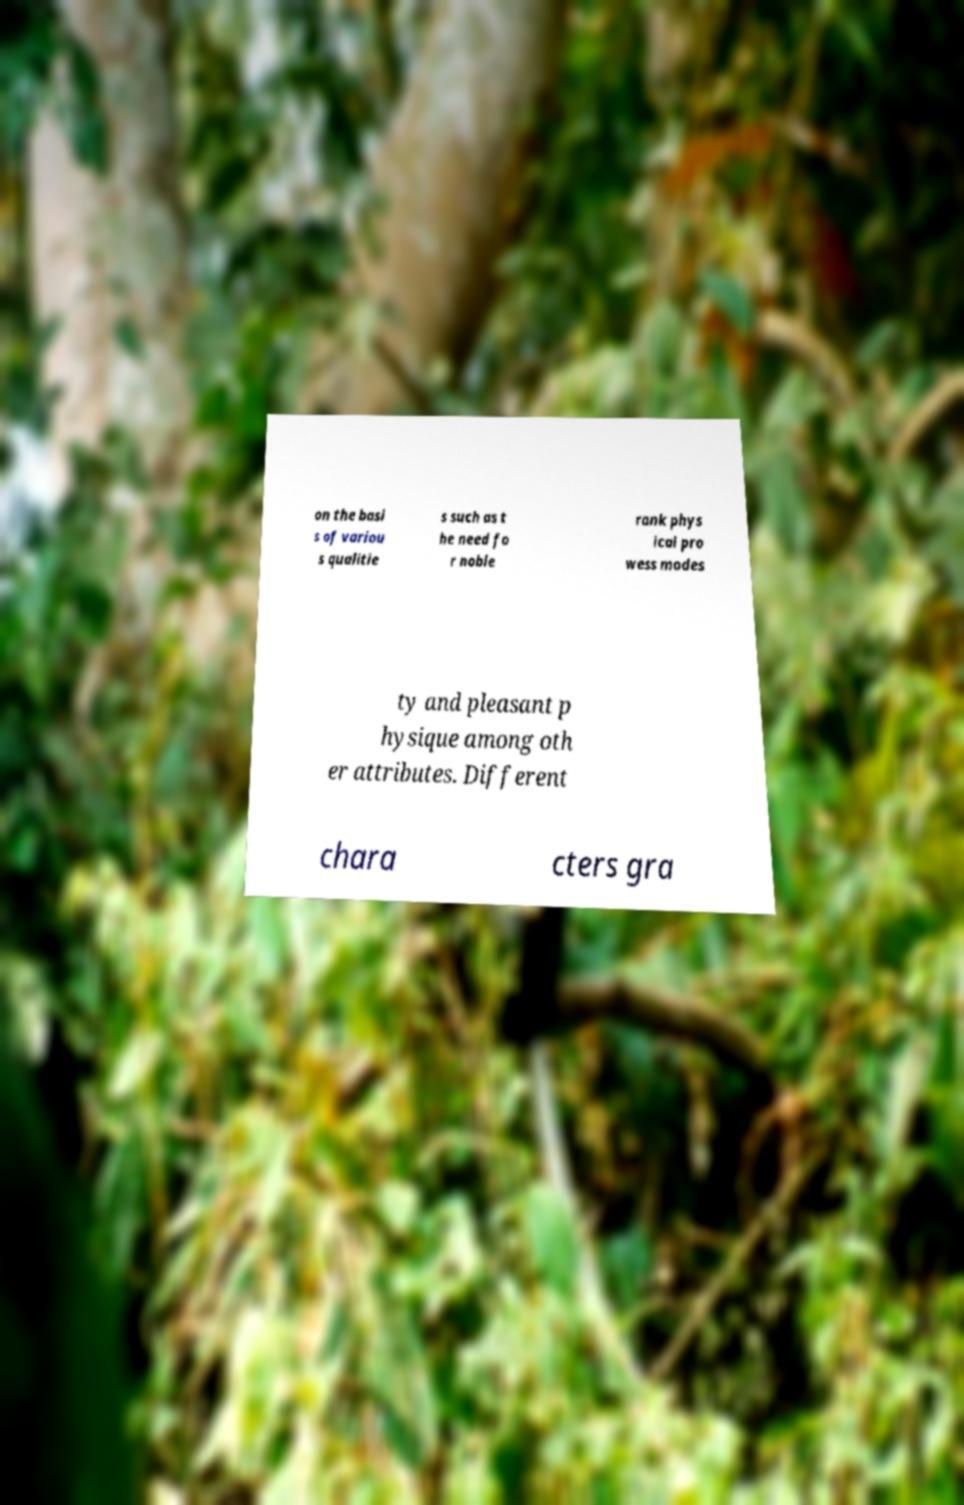There's text embedded in this image that I need extracted. Can you transcribe it verbatim? on the basi s of variou s qualitie s such as t he need fo r noble rank phys ical pro wess modes ty and pleasant p hysique among oth er attributes. Different chara cters gra 